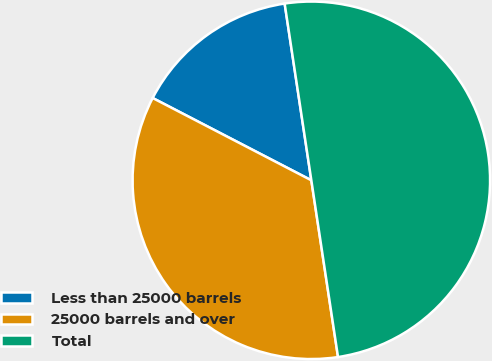Convert chart to OTSL. <chart><loc_0><loc_0><loc_500><loc_500><pie_chart><fcel>Less than 25000 barrels<fcel>25000 barrels and over<fcel>Total<nl><fcel>15.0%<fcel>35.0%<fcel>50.0%<nl></chart> 